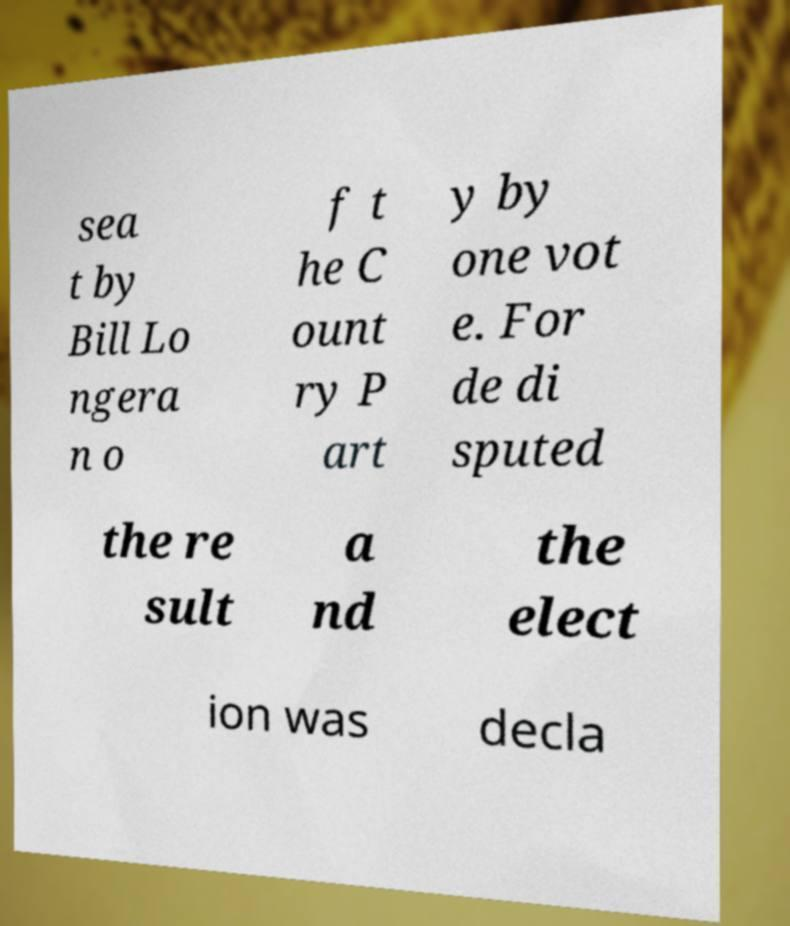I need the written content from this picture converted into text. Can you do that? sea t by Bill Lo ngera n o f t he C ount ry P art y by one vot e. For de di sputed the re sult a nd the elect ion was decla 